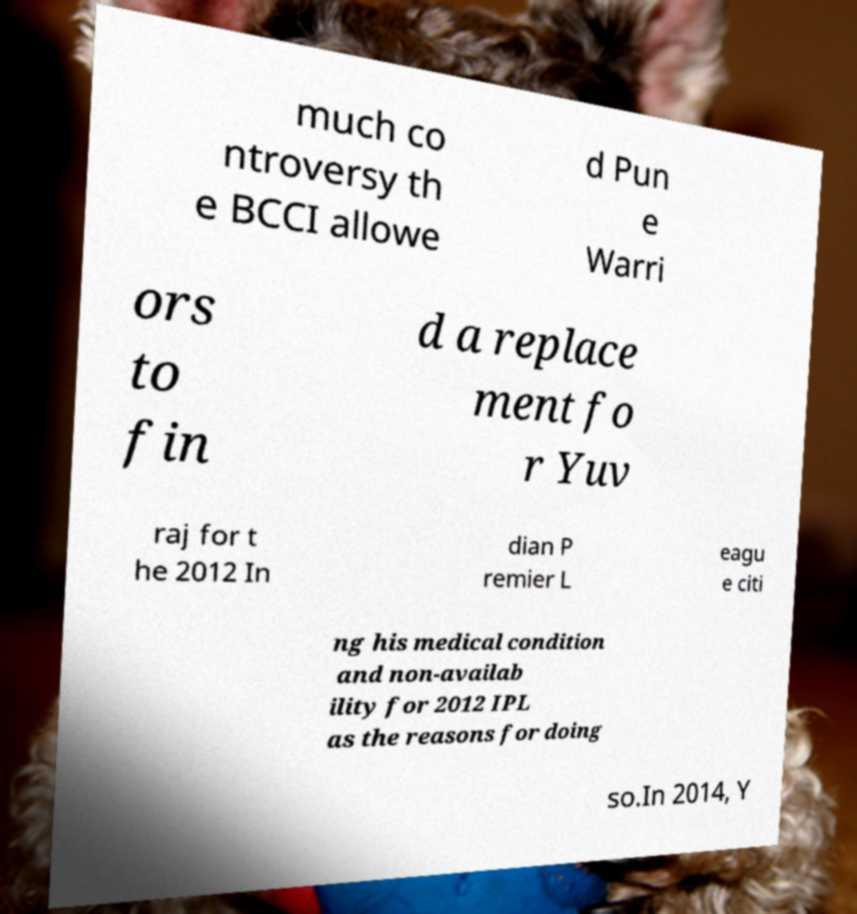Could you assist in decoding the text presented in this image and type it out clearly? much co ntroversy th e BCCI allowe d Pun e Warri ors to fin d a replace ment fo r Yuv raj for t he 2012 In dian P remier L eagu e citi ng his medical condition and non-availab ility for 2012 IPL as the reasons for doing so.In 2014, Y 